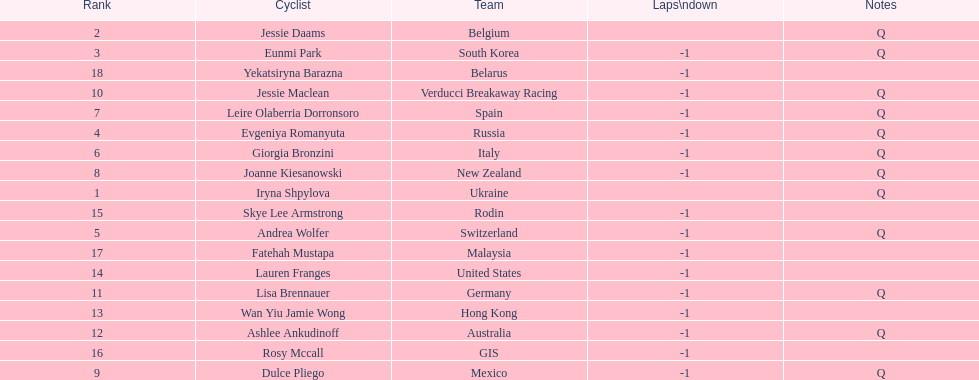How many cyclist do not have -1 laps down? 2. 